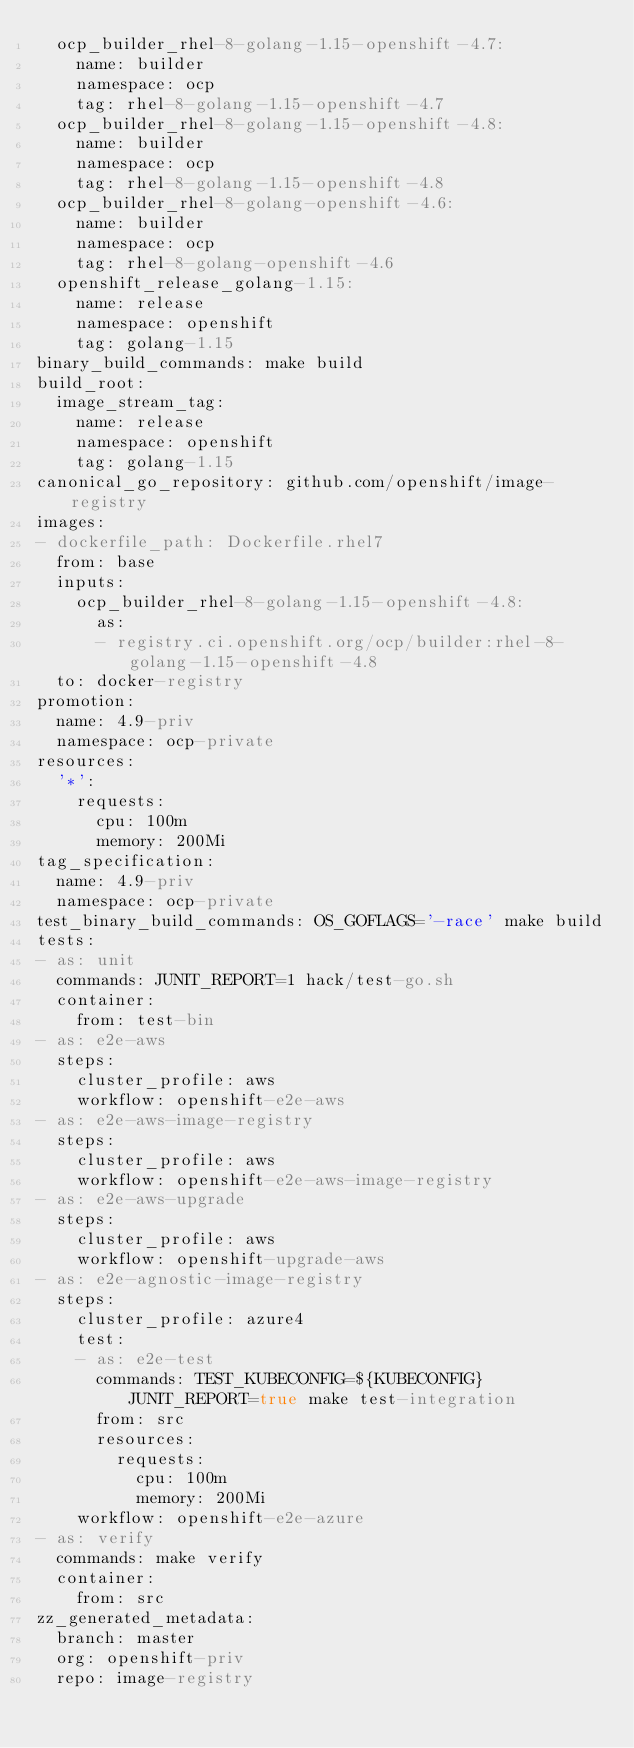<code> <loc_0><loc_0><loc_500><loc_500><_YAML_>  ocp_builder_rhel-8-golang-1.15-openshift-4.7:
    name: builder
    namespace: ocp
    tag: rhel-8-golang-1.15-openshift-4.7
  ocp_builder_rhel-8-golang-1.15-openshift-4.8:
    name: builder
    namespace: ocp
    tag: rhel-8-golang-1.15-openshift-4.8
  ocp_builder_rhel-8-golang-openshift-4.6:
    name: builder
    namespace: ocp
    tag: rhel-8-golang-openshift-4.6
  openshift_release_golang-1.15:
    name: release
    namespace: openshift
    tag: golang-1.15
binary_build_commands: make build
build_root:
  image_stream_tag:
    name: release
    namespace: openshift
    tag: golang-1.15
canonical_go_repository: github.com/openshift/image-registry
images:
- dockerfile_path: Dockerfile.rhel7
  from: base
  inputs:
    ocp_builder_rhel-8-golang-1.15-openshift-4.8:
      as:
      - registry.ci.openshift.org/ocp/builder:rhel-8-golang-1.15-openshift-4.8
  to: docker-registry
promotion:
  name: 4.9-priv
  namespace: ocp-private
resources:
  '*':
    requests:
      cpu: 100m
      memory: 200Mi
tag_specification:
  name: 4.9-priv
  namespace: ocp-private
test_binary_build_commands: OS_GOFLAGS='-race' make build
tests:
- as: unit
  commands: JUNIT_REPORT=1 hack/test-go.sh
  container:
    from: test-bin
- as: e2e-aws
  steps:
    cluster_profile: aws
    workflow: openshift-e2e-aws
- as: e2e-aws-image-registry
  steps:
    cluster_profile: aws
    workflow: openshift-e2e-aws-image-registry
- as: e2e-aws-upgrade
  steps:
    cluster_profile: aws
    workflow: openshift-upgrade-aws
- as: e2e-agnostic-image-registry
  steps:
    cluster_profile: azure4
    test:
    - as: e2e-test
      commands: TEST_KUBECONFIG=${KUBECONFIG} JUNIT_REPORT=true make test-integration
      from: src
      resources:
        requests:
          cpu: 100m
          memory: 200Mi
    workflow: openshift-e2e-azure
- as: verify
  commands: make verify
  container:
    from: src
zz_generated_metadata:
  branch: master
  org: openshift-priv
  repo: image-registry
</code> 